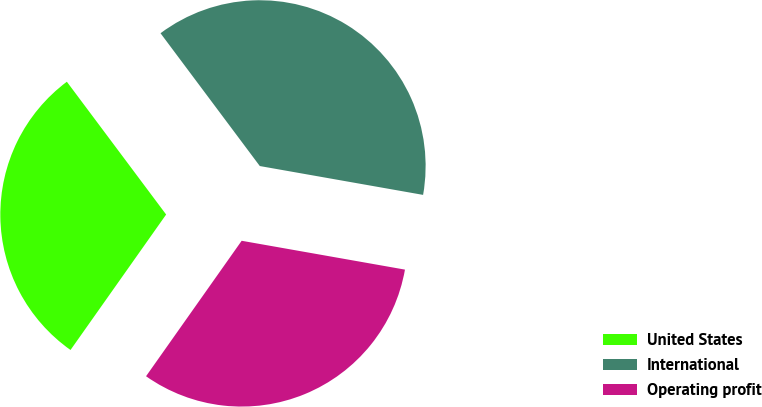<chart> <loc_0><loc_0><loc_500><loc_500><pie_chart><fcel>United States<fcel>International<fcel>Operating profit<nl><fcel>30.0%<fcel>38.0%<fcel>32.0%<nl></chart> 